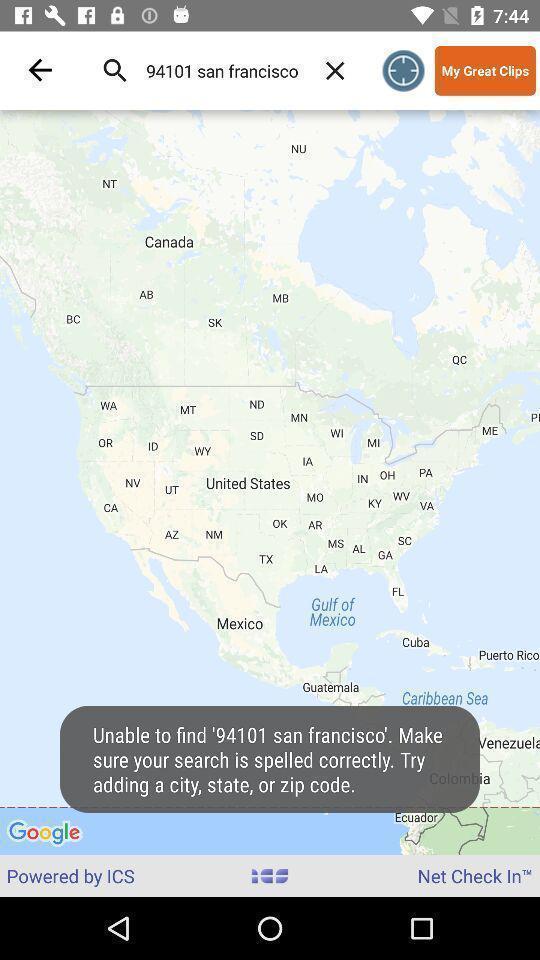Provide a detailed account of this screenshot. Page shows about the navigation app. 